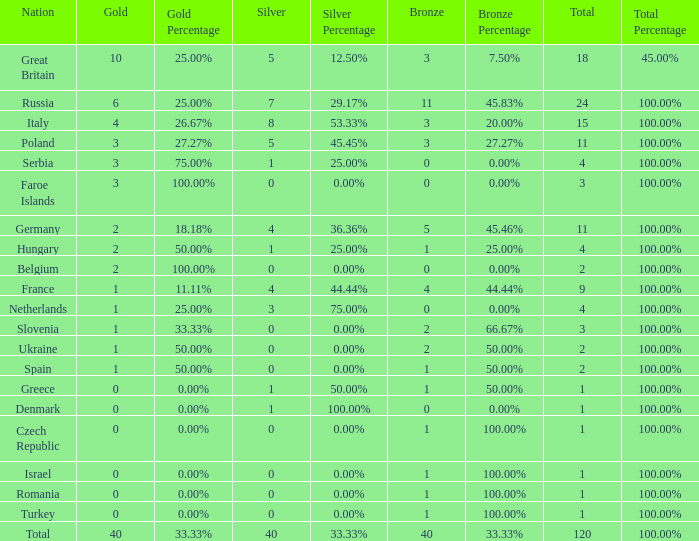What Nation has a Gold entry that is greater than 0, a Total that is greater than 2, a Silver entry that is larger than 1, and 0 Bronze? Netherlands. 